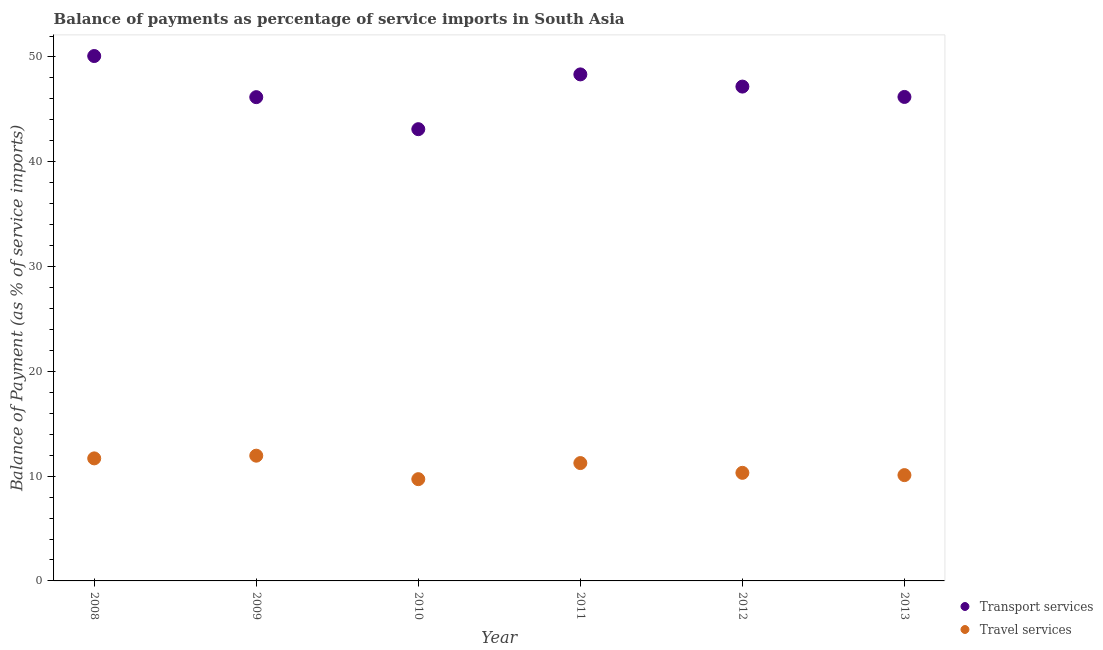What is the balance of payments of travel services in 2012?
Your answer should be compact. 10.31. Across all years, what is the maximum balance of payments of transport services?
Your response must be concise. 50.09. Across all years, what is the minimum balance of payments of transport services?
Your answer should be very brief. 43.11. In which year was the balance of payments of travel services maximum?
Offer a terse response. 2009. In which year was the balance of payments of travel services minimum?
Offer a very short reply. 2010. What is the total balance of payments of transport services in the graph?
Offer a very short reply. 281.06. What is the difference between the balance of payments of transport services in 2009 and that in 2013?
Your response must be concise. -0.02. What is the difference between the balance of payments of transport services in 2013 and the balance of payments of travel services in 2009?
Offer a terse response. 34.23. What is the average balance of payments of travel services per year?
Provide a short and direct response. 10.84. In the year 2013, what is the difference between the balance of payments of travel services and balance of payments of transport services?
Your response must be concise. -36.09. What is the ratio of the balance of payments of transport services in 2008 to that in 2013?
Offer a terse response. 1.08. Is the difference between the balance of payments of transport services in 2008 and 2010 greater than the difference between the balance of payments of travel services in 2008 and 2010?
Your answer should be very brief. Yes. What is the difference between the highest and the second highest balance of payments of transport services?
Offer a terse response. 1.75. What is the difference between the highest and the lowest balance of payments of transport services?
Provide a succinct answer. 6.98. Is the balance of payments of transport services strictly greater than the balance of payments of travel services over the years?
Ensure brevity in your answer.  Yes. How many dotlines are there?
Offer a very short reply. 2. What is the difference between two consecutive major ticks on the Y-axis?
Offer a terse response. 10. Does the graph contain any zero values?
Keep it short and to the point. No. Does the graph contain grids?
Give a very brief answer. No. How many legend labels are there?
Offer a very short reply. 2. How are the legend labels stacked?
Your answer should be very brief. Vertical. What is the title of the graph?
Keep it short and to the point. Balance of payments as percentage of service imports in South Asia. What is the label or title of the Y-axis?
Your response must be concise. Balance of Payment (as % of service imports). What is the Balance of Payment (as % of service imports) of Transport services in 2008?
Provide a succinct answer. 50.09. What is the Balance of Payment (as % of service imports) in Travel services in 2008?
Give a very brief answer. 11.69. What is the Balance of Payment (as % of service imports) in Transport services in 2009?
Provide a succinct answer. 46.17. What is the Balance of Payment (as % of service imports) of Travel services in 2009?
Your answer should be very brief. 11.95. What is the Balance of Payment (as % of service imports) of Transport services in 2010?
Your answer should be very brief. 43.11. What is the Balance of Payment (as % of service imports) in Travel services in 2010?
Give a very brief answer. 9.71. What is the Balance of Payment (as % of service imports) of Transport services in 2011?
Provide a short and direct response. 48.34. What is the Balance of Payment (as % of service imports) in Travel services in 2011?
Provide a short and direct response. 11.25. What is the Balance of Payment (as % of service imports) in Transport services in 2012?
Keep it short and to the point. 47.17. What is the Balance of Payment (as % of service imports) in Travel services in 2012?
Your answer should be compact. 10.31. What is the Balance of Payment (as % of service imports) of Transport services in 2013?
Your answer should be very brief. 46.18. What is the Balance of Payment (as % of service imports) in Travel services in 2013?
Keep it short and to the point. 10.1. Across all years, what is the maximum Balance of Payment (as % of service imports) in Transport services?
Your answer should be compact. 50.09. Across all years, what is the maximum Balance of Payment (as % of service imports) in Travel services?
Your answer should be very brief. 11.95. Across all years, what is the minimum Balance of Payment (as % of service imports) in Transport services?
Provide a short and direct response. 43.11. Across all years, what is the minimum Balance of Payment (as % of service imports) in Travel services?
Provide a succinct answer. 9.71. What is the total Balance of Payment (as % of service imports) of Transport services in the graph?
Provide a short and direct response. 281.06. What is the total Balance of Payment (as % of service imports) of Travel services in the graph?
Provide a succinct answer. 65.01. What is the difference between the Balance of Payment (as % of service imports) of Transport services in 2008 and that in 2009?
Give a very brief answer. 3.92. What is the difference between the Balance of Payment (as % of service imports) in Travel services in 2008 and that in 2009?
Your answer should be compact. -0.26. What is the difference between the Balance of Payment (as % of service imports) of Transport services in 2008 and that in 2010?
Make the answer very short. 6.98. What is the difference between the Balance of Payment (as % of service imports) in Travel services in 2008 and that in 2010?
Keep it short and to the point. 1.98. What is the difference between the Balance of Payment (as % of service imports) in Transport services in 2008 and that in 2011?
Offer a terse response. 1.75. What is the difference between the Balance of Payment (as % of service imports) of Travel services in 2008 and that in 2011?
Your response must be concise. 0.45. What is the difference between the Balance of Payment (as % of service imports) in Transport services in 2008 and that in 2012?
Provide a short and direct response. 2.92. What is the difference between the Balance of Payment (as % of service imports) in Travel services in 2008 and that in 2012?
Your answer should be compact. 1.38. What is the difference between the Balance of Payment (as % of service imports) of Transport services in 2008 and that in 2013?
Your response must be concise. 3.9. What is the difference between the Balance of Payment (as % of service imports) in Travel services in 2008 and that in 2013?
Provide a succinct answer. 1.6. What is the difference between the Balance of Payment (as % of service imports) in Transport services in 2009 and that in 2010?
Your answer should be compact. 3.06. What is the difference between the Balance of Payment (as % of service imports) of Travel services in 2009 and that in 2010?
Give a very brief answer. 2.24. What is the difference between the Balance of Payment (as % of service imports) of Transport services in 2009 and that in 2011?
Your response must be concise. -2.17. What is the difference between the Balance of Payment (as % of service imports) in Travel services in 2009 and that in 2011?
Your answer should be very brief. 0.71. What is the difference between the Balance of Payment (as % of service imports) of Transport services in 2009 and that in 2012?
Keep it short and to the point. -1.01. What is the difference between the Balance of Payment (as % of service imports) in Travel services in 2009 and that in 2012?
Your response must be concise. 1.64. What is the difference between the Balance of Payment (as % of service imports) of Transport services in 2009 and that in 2013?
Keep it short and to the point. -0.02. What is the difference between the Balance of Payment (as % of service imports) in Travel services in 2009 and that in 2013?
Give a very brief answer. 1.85. What is the difference between the Balance of Payment (as % of service imports) of Transport services in 2010 and that in 2011?
Offer a terse response. -5.23. What is the difference between the Balance of Payment (as % of service imports) in Travel services in 2010 and that in 2011?
Your answer should be compact. -1.54. What is the difference between the Balance of Payment (as % of service imports) in Transport services in 2010 and that in 2012?
Your answer should be compact. -4.06. What is the difference between the Balance of Payment (as % of service imports) of Travel services in 2010 and that in 2012?
Your answer should be very brief. -0.6. What is the difference between the Balance of Payment (as % of service imports) in Transport services in 2010 and that in 2013?
Keep it short and to the point. -3.08. What is the difference between the Balance of Payment (as % of service imports) in Travel services in 2010 and that in 2013?
Give a very brief answer. -0.39. What is the difference between the Balance of Payment (as % of service imports) in Transport services in 2011 and that in 2012?
Provide a succinct answer. 1.16. What is the difference between the Balance of Payment (as % of service imports) of Travel services in 2011 and that in 2012?
Keep it short and to the point. 0.93. What is the difference between the Balance of Payment (as % of service imports) of Transport services in 2011 and that in 2013?
Make the answer very short. 2.15. What is the difference between the Balance of Payment (as % of service imports) in Travel services in 2011 and that in 2013?
Keep it short and to the point. 1.15. What is the difference between the Balance of Payment (as % of service imports) of Transport services in 2012 and that in 2013?
Keep it short and to the point. 0.99. What is the difference between the Balance of Payment (as % of service imports) in Travel services in 2012 and that in 2013?
Provide a succinct answer. 0.22. What is the difference between the Balance of Payment (as % of service imports) in Transport services in 2008 and the Balance of Payment (as % of service imports) in Travel services in 2009?
Give a very brief answer. 38.14. What is the difference between the Balance of Payment (as % of service imports) in Transport services in 2008 and the Balance of Payment (as % of service imports) in Travel services in 2010?
Offer a terse response. 40.38. What is the difference between the Balance of Payment (as % of service imports) in Transport services in 2008 and the Balance of Payment (as % of service imports) in Travel services in 2011?
Your answer should be compact. 38.84. What is the difference between the Balance of Payment (as % of service imports) in Transport services in 2008 and the Balance of Payment (as % of service imports) in Travel services in 2012?
Your response must be concise. 39.78. What is the difference between the Balance of Payment (as % of service imports) in Transport services in 2008 and the Balance of Payment (as % of service imports) in Travel services in 2013?
Your answer should be very brief. 39.99. What is the difference between the Balance of Payment (as % of service imports) of Transport services in 2009 and the Balance of Payment (as % of service imports) of Travel services in 2010?
Provide a short and direct response. 36.45. What is the difference between the Balance of Payment (as % of service imports) of Transport services in 2009 and the Balance of Payment (as % of service imports) of Travel services in 2011?
Provide a succinct answer. 34.92. What is the difference between the Balance of Payment (as % of service imports) of Transport services in 2009 and the Balance of Payment (as % of service imports) of Travel services in 2012?
Offer a terse response. 35.85. What is the difference between the Balance of Payment (as % of service imports) of Transport services in 2009 and the Balance of Payment (as % of service imports) of Travel services in 2013?
Your answer should be very brief. 36.07. What is the difference between the Balance of Payment (as % of service imports) of Transport services in 2010 and the Balance of Payment (as % of service imports) of Travel services in 2011?
Make the answer very short. 31.86. What is the difference between the Balance of Payment (as % of service imports) of Transport services in 2010 and the Balance of Payment (as % of service imports) of Travel services in 2012?
Provide a short and direct response. 32.79. What is the difference between the Balance of Payment (as % of service imports) in Transport services in 2010 and the Balance of Payment (as % of service imports) in Travel services in 2013?
Your response must be concise. 33.01. What is the difference between the Balance of Payment (as % of service imports) in Transport services in 2011 and the Balance of Payment (as % of service imports) in Travel services in 2012?
Provide a succinct answer. 38.02. What is the difference between the Balance of Payment (as % of service imports) in Transport services in 2011 and the Balance of Payment (as % of service imports) in Travel services in 2013?
Your answer should be very brief. 38.24. What is the difference between the Balance of Payment (as % of service imports) in Transport services in 2012 and the Balance of Payment (as % of service imports) in Travel services in 2013?
Your answer should be compact. 37.08. What is the average Balance of Payment (as % of service imports) in Transport services per year?
Provide a short and direct response. 46.84. What is the average Balance of Payment (as % of service imports) of Travel services per year?
Give a very brief answer. 10.84. In the year 2008, what is the difference between the Balance of Payment (as % of service imports) of Transport services and Balance of Payment (as % of service imports) of Travel services?
Your answer should be compact. 38.4. In the year 2009, what is the difference between the Balance of Payment (as % of service imports) of Transport services and Balance of Payment (as % of service imports) of Travel services?
Your answer should be compact. 34.21. In the year 2010, what is the difference between the Balance of Payment (as % of service imports) of Transport services and Balance of Payment (as % of service imports) of Travel services?
Your answer should be compact. 33.4. In the year 2011, what is the difference between the Balance of Payment (as % of service imports) in Transport services and Balance of Payment (as % of service imports) in Travel services?
Ensure brevity in your answer.  37.09. In the year 2012, what is the difference between the Balance of Payment (as % of service imports) of Transport services and Balance of Payment (as % of service imports) of Travel services?
Your answer should be compact. 36.86. In the year 2013, what is the difference between the Balance of Payment (as % of service imports) of Transport services and Balance of Payment (as % of service imports) of Travel services?
Keep it short and to the point. 36.09. What is the ratio of the Balance of Payment (as % of service imports) of Transport services in 2008 to that in 2009?
Your answer should be compact. 1.08. What is the ratio of the Balance of Payment (as % of service imports) of Travel services in 2008 to that in 2009?
Give a very brief answer. 0.98. What is the ratio of the Balance of Payment (as % of service imports) in Transport services in 2008 to that in 2010?
Offer a terse response. 1.16. What is the ratio of the Balance of Payment (as % of service imports) of Travel services in 2008 to that in 2010?
Give a very brief answer. 1.2. What is the ratio of the Balance of Payment (as % of service imports) of Transport services in 2008 to that in 2011?
Offer a very short reply. 1.04. What is the ratio of the Balance of Payment (as % of service imports) of Travel services in 2008 to that in 2011?
Provide a succinct answer. 1.04. What is the ratio of the Balance of Payment (as % of service imports) in Transport services in 2008 to that in 2012?
Ensure brevity in your answer.  1.06. What is the ratio of the Balance of Payment (as % of service imports) of Travel services in 2008 to that in 2012?
Your answer should be compact. 1.13. What is the ratio of the Balance of Payment (as % of service imports) in Transport services in 2008 to that in 2013?
Your answer should be compact. 1.08. What is the ratio of the Balance of Payment (as % of service imports) in Travel services in 2008 to that in 2013?
Keep it short and to the point. 1.16. What is the ratio of the Balance of Payment (as % of service imports) of Transport services in 2009 to that in 2010?
Keep it short and to the point. 1.07. What is the ratio of the Balance of Payment (as % of service imports) of Travel services in 2009 to that in 2010?
Provide a succinct answer. 1.23. What is the ratio of the Balance of Payment (as % of service imports) of Transport services in 2009 to that in 2011?
Ensure brevity in your answer.  0.96. What is the ratio of the Balance of Payment (as % of service imports) in Travel services in 2009 to that in 2011?
Keep it short and to the point. 1.06. What is the ratio of the Balance of Payment (as % of service imports) in Transport services in 2009 to that in 2012?
Give a very brief answer. 0.98. What is the ratio of the Balance of Payment (as % of service imports) in Travel services in 2009 to that in 2012?
Ensure brevity in your answer.  1.16. What is the ratio of the Balance of Payment (as % of service imports) of Travel services in 2009 to that in 2013?
Give a very brief answer. 1.18. What is the ratio of the Balance of Payment (as % of service imports) in Transport services in 2010 to that in 2011?
Offer a terse response. 0.89. What is the ratio of the Balance of Payment (as % of service imports) in Travel services in 2010 to that in 2011?
Provide a short and direct response. 0.86. What is the ratio of the Balance of Payment (as % of service imports) in Transport services in 2010 to that in 2012?
Offer a terse response. 0.91. What is the ratio of the Balance of Payment (as % of service imports) in Travel services in 2010 to that in 2012?
Offer a very short reply. 0.94. What is the ratio of the Balance of Payment (as % of service imports) of Transport services in 2010 to that in 2013?
Your answer should be very brief. 0.93. What is the ratio of the Balance of Payment (as % of service imports) in Travel services in 2010 to that in 2013?
Make the answer very short. 0.96. What is the ratio of the Balance of Payment (as % of service imports) of Transport services in 2011 to that in 2012?
Provide a succinct answer. 1.02. What is the ratio of the Balance of Payment (as % of service imports) in Travel services in 2011 to that in 2012?
Offer a terse response. 1.09. What is the ratio of the Balance of Payment (as % of service imports) in Transport services in 2011 to that in 2013?
Offer a terse response. 1.05. What is the ratio of the Balance of Payment (as % of service imports) in Travel services in 2011 to that in 2013?
Your response must be concise. 1.11. What is the ratio of the Balance of Payment (as % of service imports) of Transport services in 2012 to that in 2013?
Your answer should be very brief. 1.02. What is the ratio of the Balance of Payment (as % of service imports) in Travel services in 2012 to that in 2013?
Your response must be concise. 1.02. What is the difference between the highest and the second highest Balance of Payment (as % of service imports) in Transport services?
Provide a succinct answer. 1.75. What is the difference between the highest and the second highest Balance of Payment (as % of service imports) in Travel services?
Your answer should be compact. 0.26. What is the difference between the highest and the lowest Balance of Payment (as % of service imports) of Transport services?
Make the answer very short. 6.98. What is the difference between the highest and the lowest Balance of Payment (as % of service imports) in Travel services?
Ensure brevity in your answer.  2.24. 